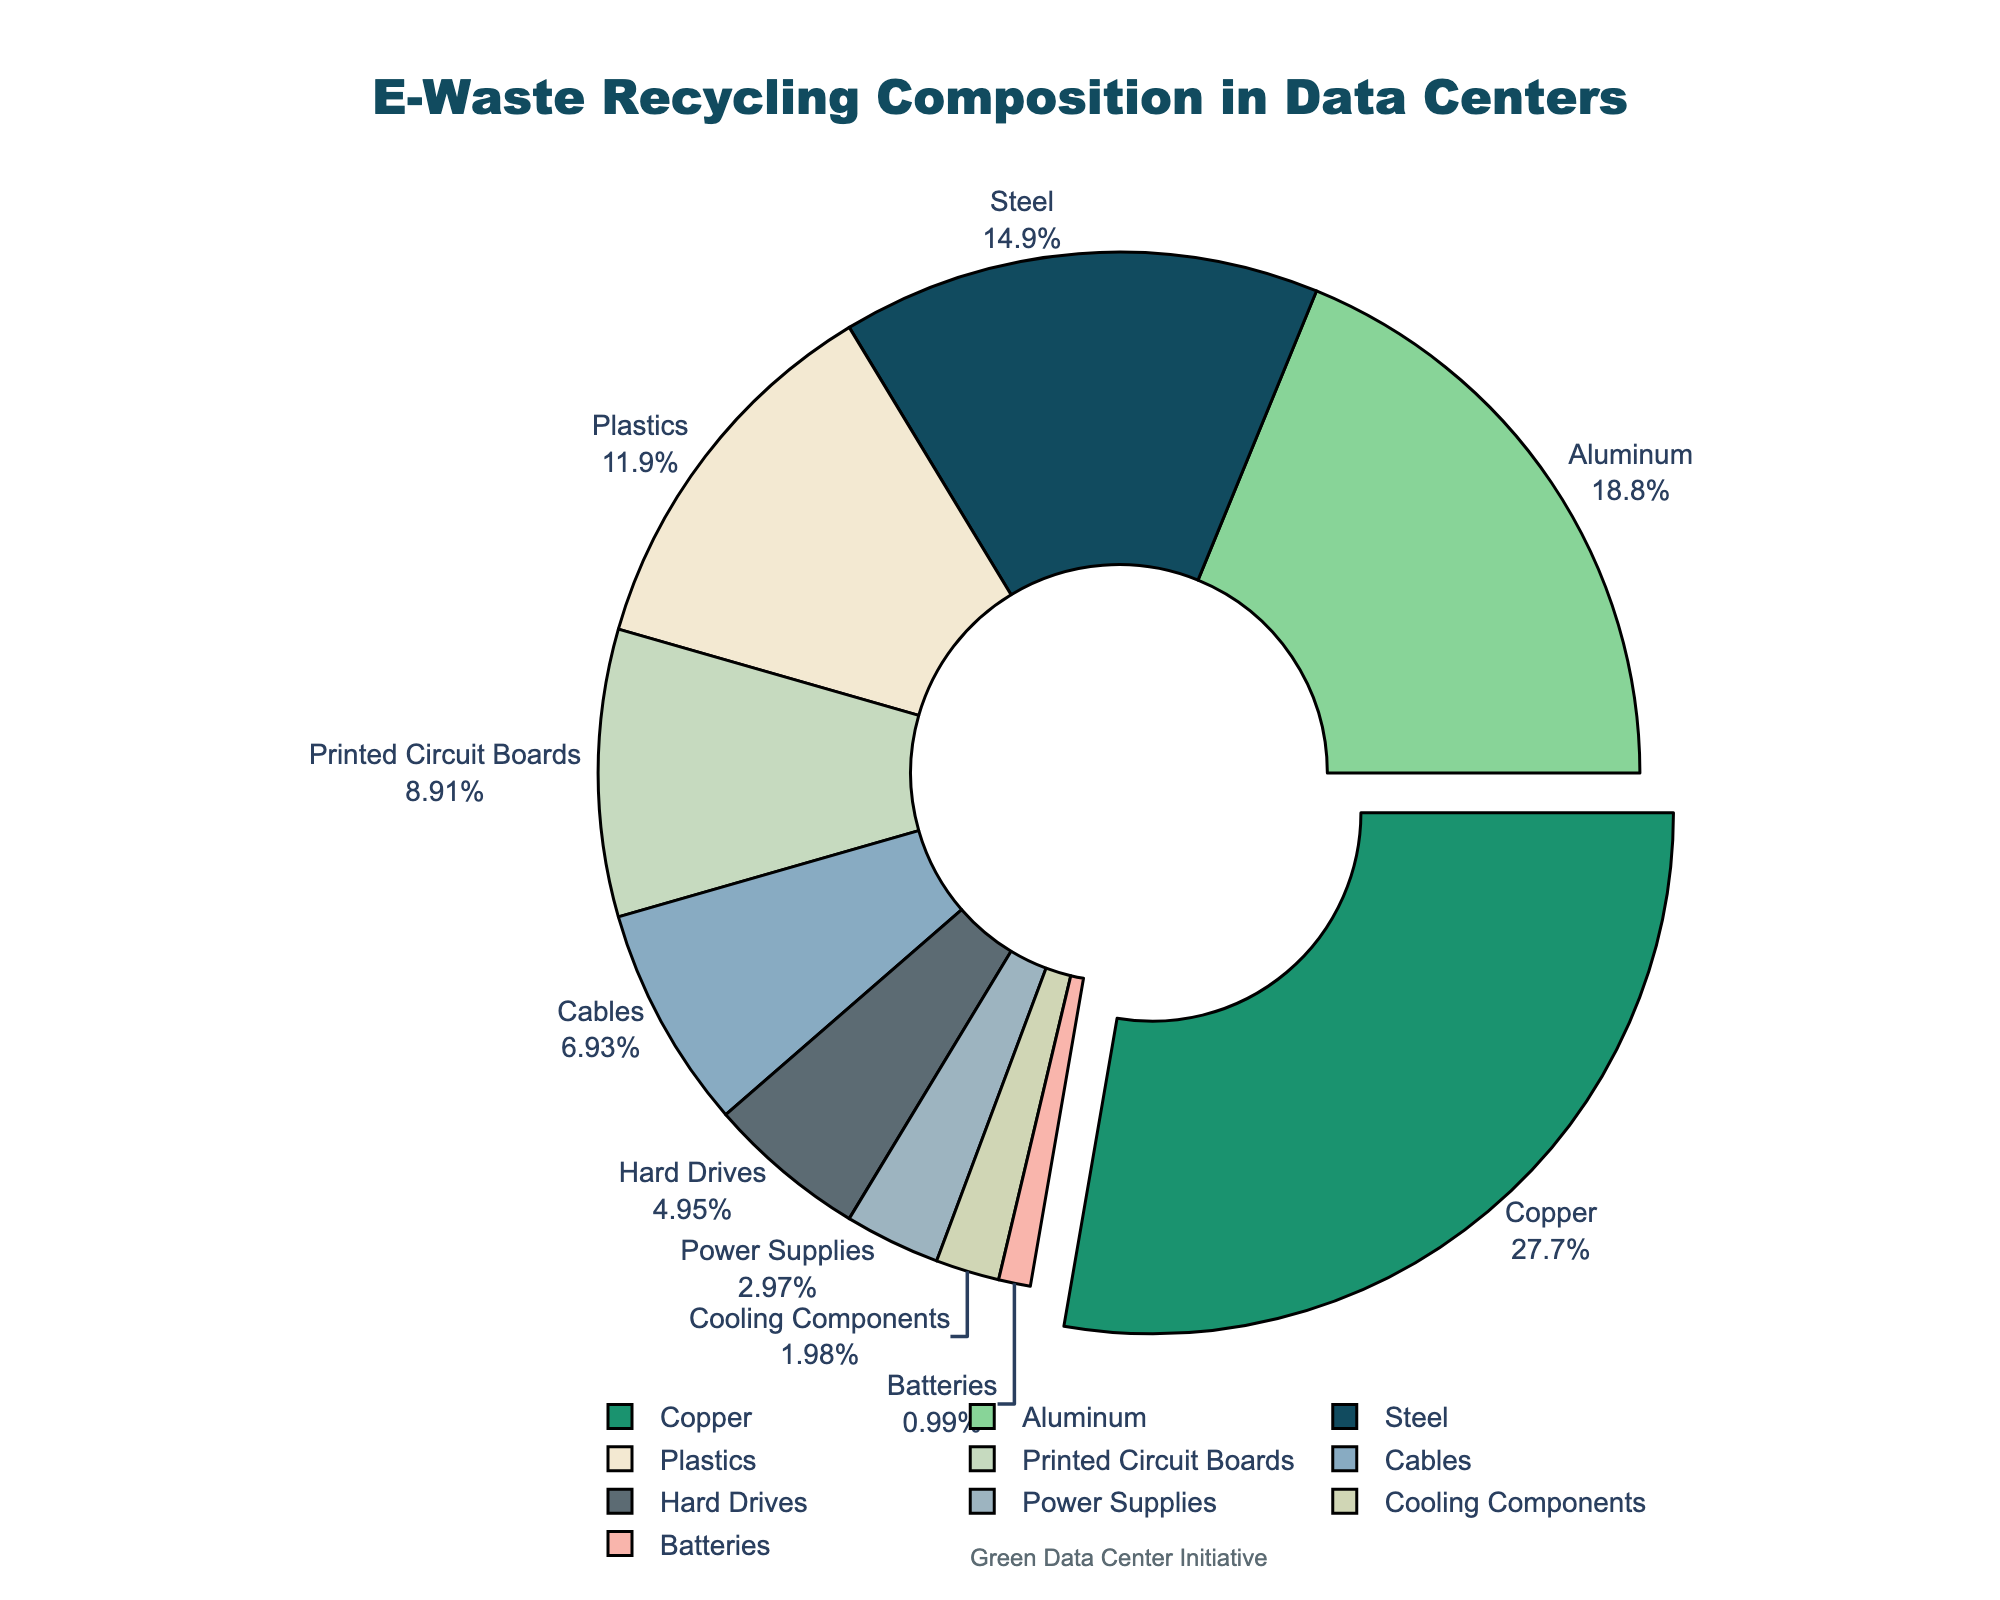What is the largest component of e-waste recycling in data centers? The largest component can be identified by looking for the material with the highest percentage. In this case, it is Copper.
Answer: Copper Which two materials together make up more than 40% of the e-waste recycling efforts? Adding the percentages of the top two materials: Copper (28%) and Aluminum (19%) gives us 47%, which is more than 40%.
Answer: Copper and Aluminum How much more percentage does Copper have compared to Steel? Copper has 28% and Steel has 15%. The difference is calculated as 28% - 15% = 13%.
Answer: 13% Which materials constitute less than 10% each of the recycling efforts? By looking at the pie chart for materials with percentages below 10%, we find: Printed Circuit Boards (9%), Cables (7%), Hard Drives (5%), Power Supplies (3%), Cooling Components (2%), and Batteries (1%).
Answer: Printed Circuit Boards, Cables, Hard Drives, Power Supplies, Cooling Components, Batteries What is the total percentage of materials that make up 5% or less of the e-waste recycling efforts? Adding up the percentages: Hard Drives (5%), Power Supplies (3%), Cooling Components (2%), and Batteries (1%) gives us 5% + 3% + 2% + 1% = 11%.
Answer: 11% Which materials are shown in shades of green? Reviewing the pie chart colors, Copper (28%) and Aluminum (19%) are displayed in shades of green.
Answer: Copper and Aluminum How many more percent of e-waste recycling efforts are constituted by Plastics compared to Hard Drives? Plastics make up 12% and Hard Drives make up 5%. The difference is 12% - 5% = 7%.
Answer: 7% What is the combined percentage of Steel and Plastics in e-waste recycling efforts? Adding the percentages of Steel (15%) and Plastics (12%) gives us 15% + 12% = 27%.
Answer: 27% 